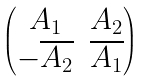<formula> <loc_0><loc_0><loc_500><loc_500>\begin{pmatrix} A _ { 1 } & A _ { 2 } \\ - \overline { A _ { 2 } } & \overline { A _ { 1 } } \end{pmatrix}</formula> 